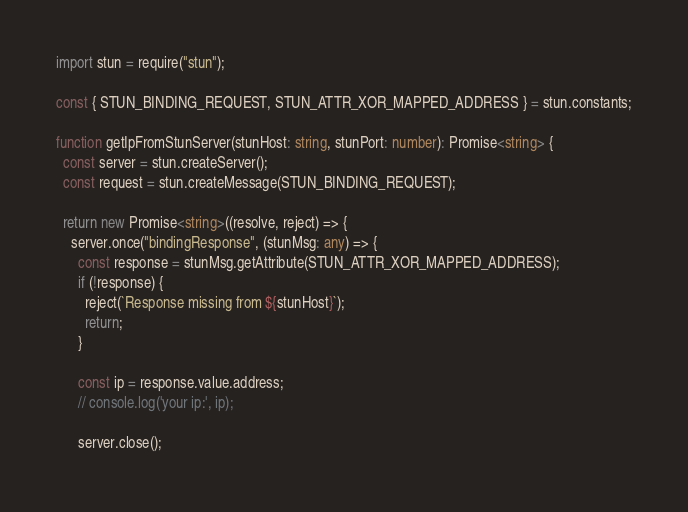<code> <loc_0><loc_0><loc_500><loc_500><_TypeScript_>import stun = require("stun");

const { STUN_BINDING_REQUEST, STUN_ATTR_XOR_MAPPED_ADDRESS } = stun.constants;

function getIpFromStunServer(stunHost: string, stunPort: number): Promise<string> {
  const server = stun.createServer();
  const request = stun.createMessage(STUN_BINDING_REQUEST);

  return new Promise<string>((resolve, reject) => {
    server.once("bindingResponse", (stunMsg: any) => {
      const response = stunMsg.getAttribute(STUN_ATTR_XOR_MAPPED_ADDRESS);
      if (!response) {
        reject(`Response missing from ${stunHost}`);
        return;
      }

      const ip = response.value.address;
      // console.log('your ip:', ip);

      server.close();</code> 